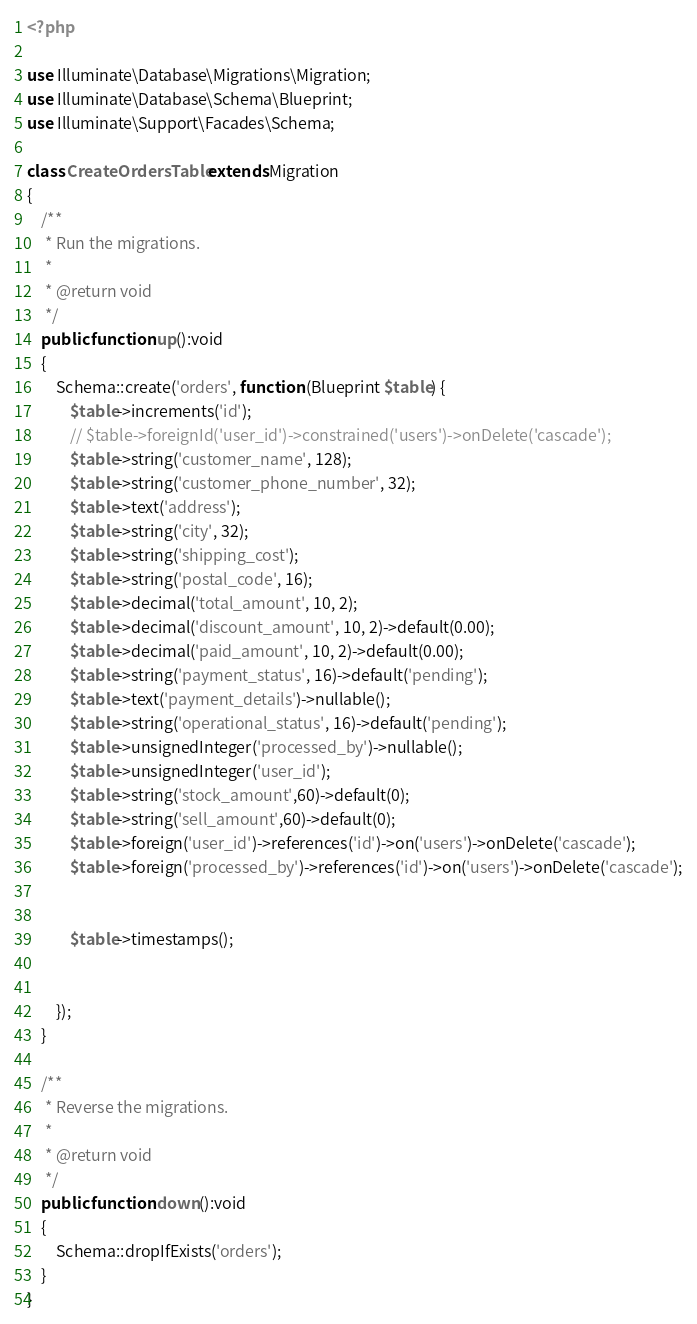<code> <loc_0><loc_0><loc_500><loc_500><_PHP_><?php

use Illuminate\Database\Migrations\Migration;
use Illuminate\Database\Schema\Blueprint;
use Illuminate\Support\Facades\Schema;

class CreateOrdersTable extends Migration
{
    /**
     * Run the migrations.
     *
     * @return void
     */
    public function up():void
    {
        Schema::create('orders', function (Blueprint $table) {
            $table->increments('id');
            // $table->foreignId('user_id')->constrained('users')->onDelete('cascade');
            $table->string('customer_name', 128);
            $table->string('customer_phone_number', 32);
            $table->text('address');
            $table->string('city', 32);
            $table->string('shipping_cost');
            $table->string('postal_code', 16);
            $table->decimal('total_amount', 10, 2);
            $table->decimal('discount_amount', 10, 2)->default(0.00);
            $table->decimal('paid_amount', 10, 2)->default(0.00);
            $table->string('payment_status', 16)->default('pending');
            $table->text('payment_details')->nullable();
            $table->string('operational_status', 16)->default('pending');
            $table->unsignedInteger('processed_by')->nullable();
            $table->unsignedInteger('user_id');
            $table->string('stock_amount',60)->default(0);
            $table->string('sell_amount',60)->default(0);
            $table->foreign('user_id')->references('id')->on('users')->onDelete('cascade');
            $table->foreign('processed_by')->references('id')->on('users')->onDelete('cascade');


            $table->timestamps();

            
        });
    }

    /**
     * Reverse the migrations.
     *
     * @return void
     */
    public function down():void
    {
        Schema::dropIfExists('orders');
    }
}
</code> 